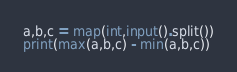Convert code to text. <code><loc_0><loc_0><loc_500><loc_500><_Python_>a,b,c = map(int,input().split())
print(max(a,b,c) - min(a,b,c))</code> 